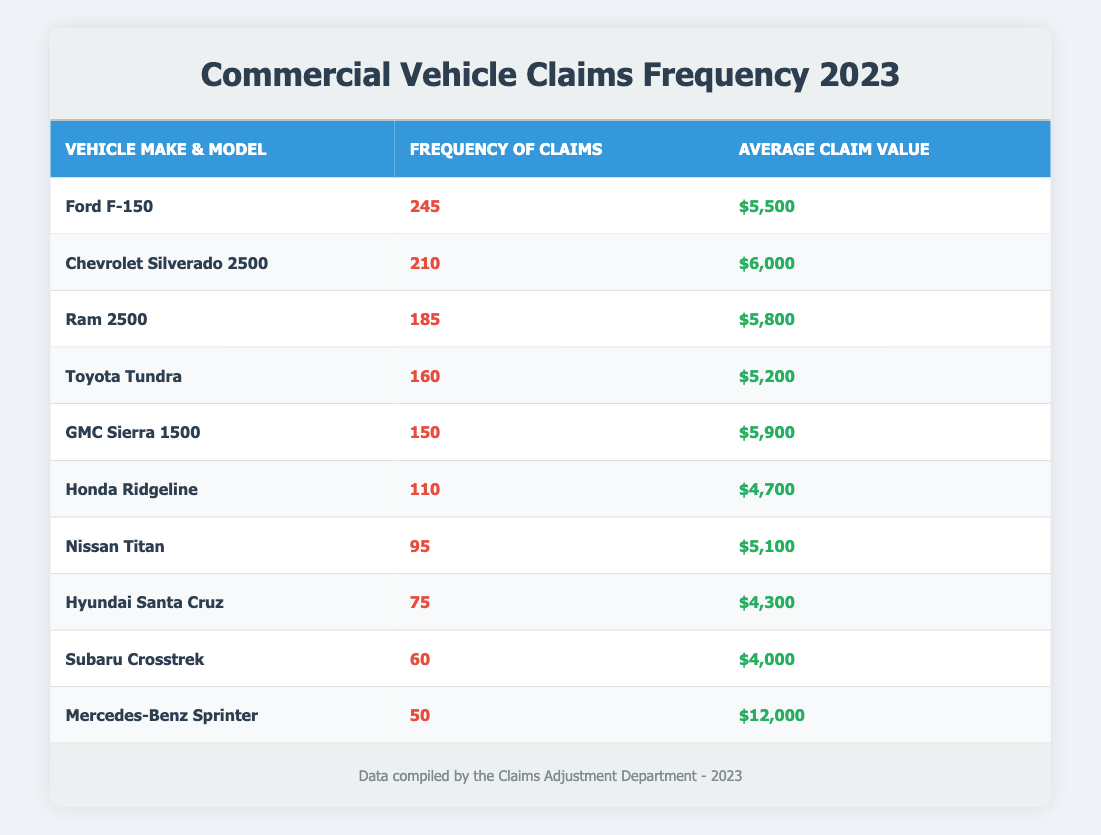What is the make and model of the vehicle with the highest frequency of claims? The highest frequency of claims listed is 245, which corresponds to the make and model Ford F-150.
Answer: Ford F-150 What is the average claim value for the GMC Sierra 1500? The table shows that the average claim value for the GMC Sierra 1500 is $5,900.
Answer: $5,900 Which vehicle make has the least frequency of claims? The vehicle make with the least frequency of claims is Mercedes-Benz, with only 50 claims.
Answer: Mercedes-Benz How many total claims were there for the top three vehicles? The top three vehicles have frequencies of 245 (Ford F-150), 210 (Chevrolet Silverado 2500), and 185 (Ram 2500). The total is 245 + 210 + 185 = 640 claims.
Answer: 640 Is the average claim value for the Toyota Tundra higher than that of the Honda Ridgeline? The average claim value for the Toyota Tundra is $5,200, while the Honda Ridgeline has an average claim value of $4,700. Since $5,200 is greater than $4,700, the statement is true.
Answer: Yes What is the difference in frequency of claims between the Ford F-150 and the Honda Ridgeline? The frequency of claims for the Ford F-150 is 245 and for the Honda Ridgeline it is 110. The difference is 245 - 110 = 135 claims.
Answer: 135 What percentage of claims does the Nissan Titan represent compared to the total claims of all vehicles listed? The total claims across all vehicles are 1,445 (sum of all frequencies). The Nissan Titan has 95 claims, so the percentage is (95 / 1445) * 100 ≈ 6.57%.
Answer: 6.57% How many vehicles have an average claim value below $5,000? The average claim values listed are $5,500, $6,000, $5,800, $5,200, $5,900, $4,700, $5,100, $4,300, $4,000, and $12,000. Only the Hyundai Santa Cruz ($4,300) and Subaru Crosstrek ($4,000) are below $5,000, making a total of 2 vehicles.
Answer: 2 Which vehicle make has a higher average claim value, Chevy or Ford? The average claim value for Chevrolet Silverado 2500 is $6,000, while for Ford F-150 it is $5,500; since $6,000 is greater, Chevrolet has a higher average claim value.
Answer: Chevrolet 